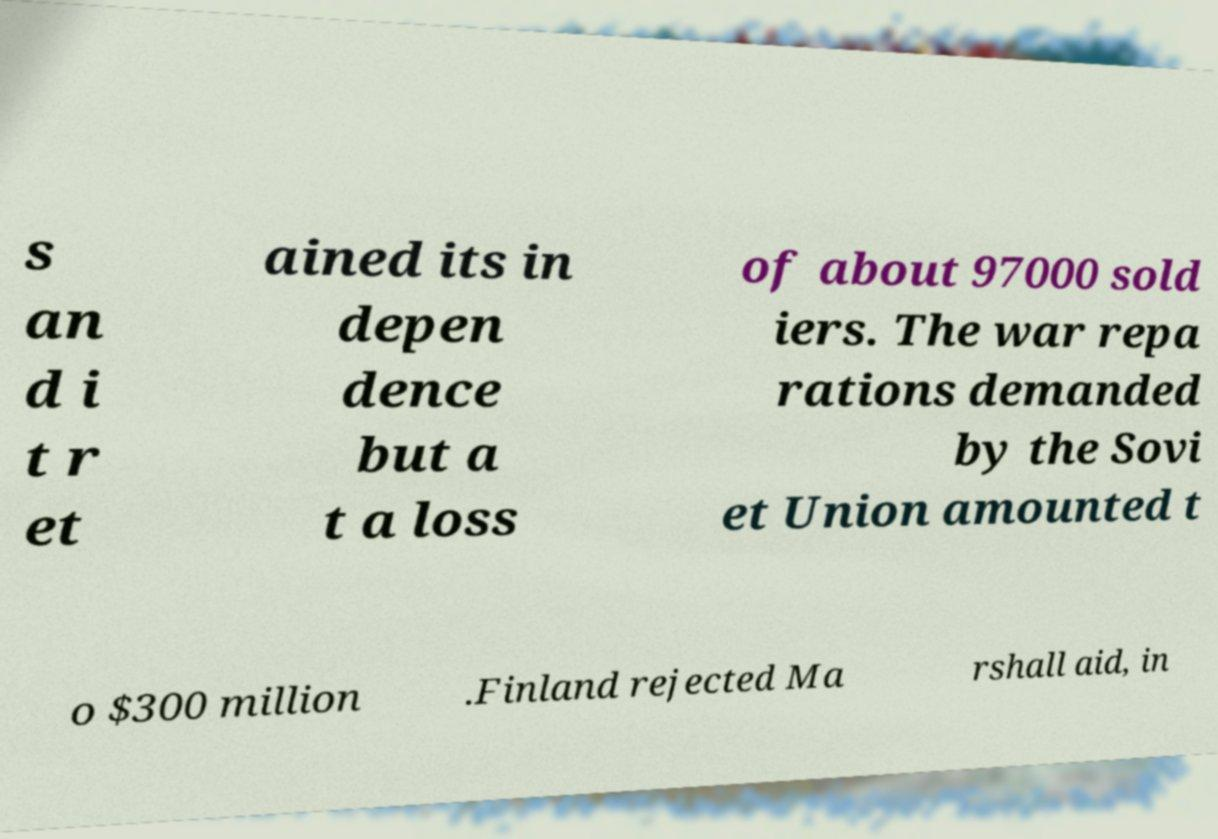Please identify and transcribe the text found in this image. s an d i t r et ained its in depen dence but a t a loss of about 97000 sold iers. The war repa rations demanded by the Sovi et Union amounted t o $300 million .Finland rejected Ma rshall aid, in 